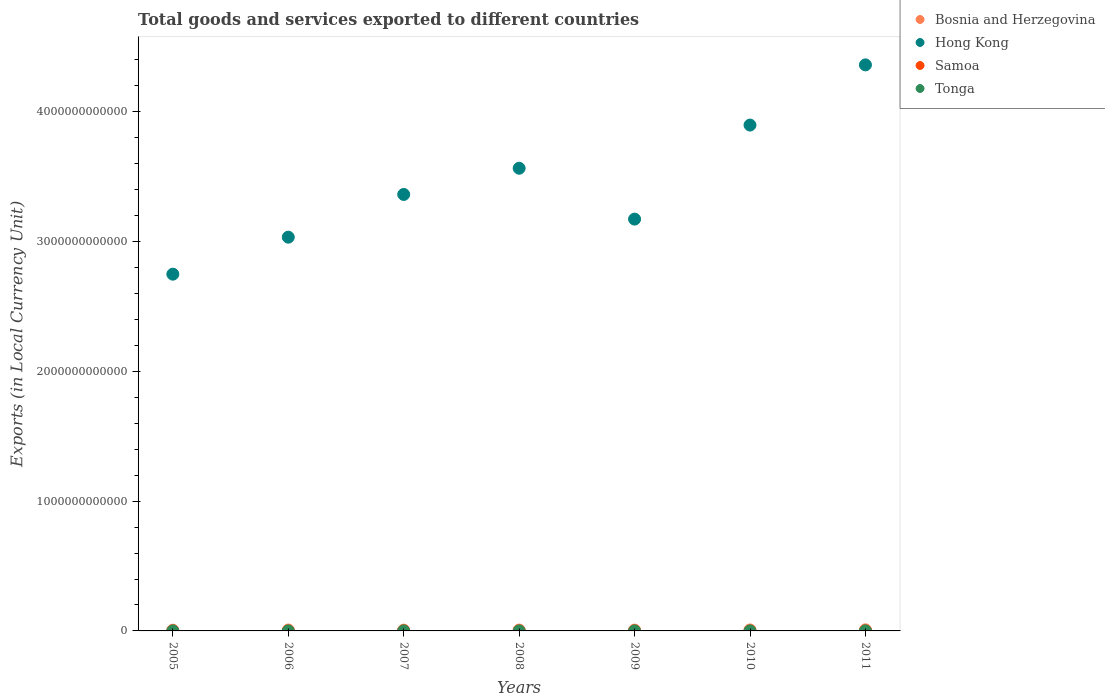Is the number of dotlines equal to the number of legend labels?
Your answer should be very brief. Yes. What is the Amount of goods and services exports in Samoa in 2008?
Offer a terse response. 4.74e+08. Across all years, what is the maximum Amount of goods and services exports in Tonga?
Make the answer very short. 1.29e+08. Across all years, what is the minimum Amount of goods and services exports in Tonga?
Make the answer very short. 7.31e+07. In which year was the Amount of goods and services exports in Tonga minimum?
Offer a terse response. 2007. What is the total Amount of goods and services exports in Samoa in the graph?
Ensure brevity in your answer.  3.15e+09. What is the difference between the Amount of goods and services exports in Bosnia and Herzegovina in 2006 and that in 2011?
Give a very brief answer. -1.38e+09. What is the difference between the Amount of goods and services exports in Hong Kong in 2005 and the Amount of goods and services exports in Samoa in 2010?
Your response must be concise. 2.75e+12. What is the average Amount of goods and services exports in Tonga per year?
Your answer should be very brief. 9.30e+07. In the year 2007, what is the difference between the Amount of goods and services exports in Hong Kong and Amount of goods and services exports in Bosnia and Herzegovina?
Provide a succinct answer. 3.36e+12. What is the ratio of the Amount of goods and services exports in Bosnia and Herzegovina in 2005 to that in 2007?
Your answer should be compact. 0.91. Is the difference between the Amount of goods and services exports in Hong Kong in 2006 and 2011 greater than the difference between the Amount of goods and services exports in Bosnia and Herzegovina in 2006 and 2011?
Ensure brevity in your answer.  No. What is the difference between the highest and the second highest Amount of goods and services exports in Samoa?
Ensure brevity in your answer.  2.37e+07. What is the difference between the highest and the lowest Amount of goods and services exports in Bosnia and Herzegovina?
Provide a succinct answer. 2.82e+09. Is the sum of the Amount of goods and services exports in Tonga in 2005 and 2009 greater than the maximum Amount of goods and services exports in Samoa across all years?
Offer a terse response. No. Is it the case that in every year, the sum of the Amount of goods and services exports in Tonga and Amount of goods and services exports in Hong Kong  is greater than the Amount of goods and services exports in Bosnia and Herzegovina?
Ensure brevity in your answer.  Yes. Does the Amount of goods and services exports in Samoa monotonically increase over the years?
Your answer should be very brief. No. Is the Amount of goods and services exports in Hong Kong strictly greater than the Amount of goods and services exports in Bosnia and Herzegovina over the years?
Give a very brief answer. Yes. Is the Amount of goods and services exports in Samoa strictly less than the Amount of goods and services exports in Bosnia and Herzegovina over the years?
Your answer should be compact. Yes. How many dotlines are there?
Ensure brevity in your answer.  4. How many years are there in the graph?
Offer a very short reply. 7. What is the difference between two consecutive major ticks on the Y-axis?
Your answer should be compact. 1.00e+12. Does the graph contain grids?
Give a very brief answer. No. How are the legend labels stacked?
Your answer should be very brief. Vertical. What is the title of the graph?
Offer a terse response. Total goods and services exported to different countries. What is the label or title of the X-axis?
Offer a very short reply. Years. What is the label or title of the Y-axis?
Offer a very short reply. Exports (in Local Currency Unit). What is the Exports (in Local Currency Unit) in Bosnia and Herzegovina in 2005?
Ensure brevity in your answer.  5.58e+09. What is the Exports (in Local Currency Unit) in Hong Kong in 2005?
Make the answer very short. 2.75e+12. What is the Exports (in Local Currency Unit) in Samoa in 2005?
Your answer should be very brief. 3.58e+08. What is the Exports (in Local Currency Unit) in Tonga in 2005?
Ensure brevity in your answer.  9.05e+07. What is the Exports (in Local Currency Unit) of Bosnia and Herzegovina in 2006?
Your answer should be very brief. 7.02e+09. What is the Exports (in Local Currency Unit) in Hong Kong in 2006?
Keep it short and to the point. 3.03e+12. What is the Exports (in Local Currency Unit) in Samoa in 2006?
Your response must be concise. 4.07e+08. What is the Exports (in Local Currency Unit) of Tonga in 2006?
Offer a very short reply. 8.55e+07. What is the Exports (in Local Currency Unit) of Bosnia and Herzegovina in 2007?
Keep it short and to the point. 6.11e+09. What is the Exports (in Local Currency Unit) of Hong Kong in 2007?
Your answer should be very brief. 3.36e+12. What is the Exports (in Local Currency Unit) of Samoa in 2007?
Make the answer very short. 4.44e+08. What is the Exports (in Local Currency Unit) of Tonga in 2007?
Ensure brevity in your answer.  7.31e+07. What is the Exports (in Local Currency Unit) of Bosnia and Herzegovina in 2008?
Provide a short and direct response. 6.85e+09. What is the Exports (in Local Currency Unit) of Hong Kong in 2008?
Your answer should be compact. 3.56e+12. What is the Exports (in Local Currency Unit) in Samoa in 2008?
Provide a succinct answer. 4.74e+08. What is the Exports (in Local Currency Unit) of Tonga in 2008?
Provide a succinct answer. 9.04e+07. What is the Exports (in Local Currency Unit) in Bosnia and Herzegovina in 2009?
Offer a very short reply. 6.20e+09. What is the Exports (in Local Currency Unit) in Hong Kong in 2009?
Ensure brevity in your answer.  3.17e+12. What is the Exports (in Local Currency Unit) of Samoa in 2009?
Your response must be concise. 4.83e+08. What is the Exports (in Local Currency Unit) of Tonga in 2009?
Make the answer very short. 9.32e+07. What is the Exports (in Local Currency Unit) of Bosnia and Herzegovina in 2010?
Offer a very short reply. 7.53e+09. What is the Exports (in Local Currency Unit) of Hong Kong in 2010?
Offer a very short reply. 3.90e+12. What is the Exports (in Local Currency Unit) in Samoa in 2010?
Provide a short and direct response. 4.77e+08. What is the Exports (in Local Currency Unit) of Tonga in 2010?
Your answer should be very brief. 8.99e+07. What is the Exports (in Local Currency Unit) in Bosnia and Herzegovina in 2011?
Ensure brevity in your answer.  8.40e+09. What is the Exports (in Local Currency Unit) in Hong Kong in 2011?
Provide a succinct answer. 4.36e+12. What is the Exports (in Local Currency Unit) of Samoa in 2011?
Provide a short and direct response. 5.07e+08. What is the Exports (in Local Currency Unit) of Tonga in 2011?
Give a very brief answer. 1.29e+08. Across all years, what is the maximum Exports (in Local Currency Unit) in Bosnia and Herzegovina?
Provide a succinct answer. 8.40e+09. Across all years, what is the maximum Exports (in Local Currency Unit) in Hong Kong?
Keep it short and to the point. 4.36e+12. Across all years, what is the maximum Exports (in Local Currency Unit) in Samoa?
Your answer should be compact. 5.07e+08. Across all years, what is the maximum Exports (in Local Currency Unit) of Tonga?
Your response must be concise. 1.29e+08. Across all years, what is the minimum Exports (in Local Currency Unit) of Bosnia and Herzegovina?
Offer a terse response. 5.58e+09. Across all years, what is the minimum Exports (in Local Currency Unit) of Hong Kong?
Offer a very short reply. 2.75e+12. Across all years, what is the minimum Exports (in Local Currency Unit) in Samoa?
Keep it short and to the point. 3.58e+08. Across all years, what is the minimum Exports (in Local Currency Unit) in Tonga?
Make the answer very short. 7.31e+07. What is the total Exports (in Local Currency Unit) of Bosnia and Herzegovina in the graph?
Provide a short and direct response. 4.77e+1. What is the total Exports (in Local Currency Unit) in Hong Kong in the graph?
Give a very brief answer. 2.41e+13. What is the total Exports (in Local Currency Unit) of Samoa in the graph?
Offer a very short reply. 3.15e+09. What is the total Exports (in Local Currency Unit) of Tonga in the graph?
Offer a terse response. 6.51e+08. What is the difference between the Exports (in Local Currency Unit) of Bosnia and Herzegovina in 2005 and that in 2006?
Provide a succinct answer. -1.44e+09. What is the difference between the Exports (in Local Currency Unit) of Hong Kong in 2005 and that in 2006?
Ensure brevity in your answer.  -2.85e+11. What is the difference between the Exports (in Local Currency Unit) of Samoa in 2005 and that in 2006?
Offer a very short reply. -4.83e+07. What is the difference between the Exports (in Local Currency Unit) of Tonga in 2005 and that in 2006?
Make the answer very short. 5.07e+06. What is the difference between the Exports (in Local Currency Unit) of Bosnia and Herzegovina in 2005 and that in 2007?
Ensure brevity in your answer.  -5.28e+08. What is the difference between the Exports (in Local Currency Unit) of Hong Kong in 2005 and that in 2007?
Your answer should be very brief. -6.14e+11. What is the difference between the Exports (in Local Currency Unit) of Samoa in 2005 and that in 2007?
Provide a short and direct response. -8.52e+07. What is the difference between the Exports (in Local Currency Unit) in Tonga in 2005 and that in 2007?
Ensure brevity in your answer.  1.75e+07. What is the difference between the Exports (in Local Currency Unit) in Bosnia and Herzegovina in 2005 and that in 2008?
Ensure brevity in your answer.  -1.27e+09. What is the difference between the Exports (in Local Currency Unit) of Hong Kong in 2005 and that in 2008?
Your answer should be very brief. -8.16e+11. What is the difference between the Exports (in Local Currency Unit) of Samoa in 2005 and that in 2008?
Give a very brief answer. -1.15e+08. What is the difference between the Exports (in Local Currency Unit) in Tonga in 2005 and that in 2008?
Provide a succinct answer. 1.49e+05. What is the difference between the Exports (in Local Currency Unit) in Bosnia and Herzegovina in 2005 and that in 2009?
Ensure brevity in your answer.  -6.19e+08. What is the difference between the Exports (in Local Currency Unit) in Hong Kong in 2005 and that in 2009?
Ensure brevity in your answer.  -4.24e+11. What is the difference between the Exports (in Local Currency Unit) of Samoa in 2005 and that in 2009?
Give a very brief answer. -1.25e+08. What is the difference between the Exports (in Local Currency Unit) of Tonga in 2005 and that in 2009?
Your answer should be very brief. -2.63e+06. What is the difference between the Exports (in Local Currency Unit) of Bosnia and Herzegovina in 2005 and that in 2010?
Provide a succinct answer. -1.95e+09. What is the difference between the Exports (in Local Currency Unit) of Hong Kong in 2005 and that in 2010?
Your answer should be very brief. -1.15e+12. What is the difference between the Exports (in Local Currency Unit) of Samoa in 2005 and that in 2010?
Your answer should be very brief. -1.18e+08. What is the difference between the Exports (in Local Currency Unit) in Tonga in 2005 and that in 2010?
Provide a short and direct response. 6.74e+05. What is the difference between the Exports (in Local Currency Unit) of Bosnia and Herzegovina in 2005 and that in 2011?
Provide a succinct answer. -2.82e+09. What is the difference between the Exports (in Local Currency Unit) of Hong Kong in 2005 and that in 2011?
Provide a succinct answer. -1.61e+12. What is the difference between the Exports (in Local Currency Unit) of Samoa in 2005 and that in 2011?
Provide a short and direct response. -1.49e+08. What is the difference between the Exports (in Local Currency Unit) in Tonga in 2005 and that in 2011?
Your answer should be compact. -3.80e+07. What is the difference between the Exports (in Local Currency Unit) of Bosnia and Herzegovina in 2006 and that in 2007?
Keep it short and to the point. 9.14e+08. What is the difference between the Exports (in Local Currency Unit) in Hong Kong in 2006 and that in 2007?
Your response must be concise. -3.29e+11. What is the difference between the Exports (in Local Currency Unit) of Samoa in 2006 and that in 2007?
Your answer should be compact. -3.69e+07. What is the difference between the Exports (in Local Currency Unit) in Tonga in 2006 and that in 2007?
Give a very brief answer. 1.24e+07. What is the difference between the Exports (in Local Currency Unit) of Bosnia and Herzegovina in 2006 and that in 2008?
Provide a short and direct response. 1.73e+08. What is the difference between the Exports (in Local Currency Unit) in Hong Kong in 2006 and that in 2008?
Make the answer very short. -5.31e+11. What is the difference between the Exports (in Local Currency Unit) of Samoa in 2006 and that in 2008?
Keep it short and to the point. -6.71e+07. What is the difference between the Exports (in Local Currency Unit) of Tonga in 2006 and that in 2008?
Your response must be concise. -4.92e+06. What is the difference between the Exports (in Local Currency Unit) in Bosnia and Herzegovina in 2006 and that in 2009?
Provide a succinct answer. 8.22e+08. What is the difference between the Exports (in Local Currency Unit) in Hong Kong in 2006 and that in 2009?
Offer a very short reply. -1.39e+11. What is the difference between the Exports (in Local Currency Unit) of Samoa in 2006 and that in 2009?
Ensure brevity in your answer.  -7.65e+07. What is the difference between the Exports (in Local Currency Unit) of Tonga in 2006 and that in 2009?
Give a very brief answer. -7.70e+06. What is the difference between the Exports (in Local Currency Unit) in Bosnia and Herzegovina in 2006 and that in 2010?
Provide a short and direct response. -5.08e+08. What is the difference between the Exports (in Local Currency Unit) of Hong Kong in 2006 and that in 2010?
Offer a terse response. -8.64e+11. What is the difference between the Exports (in Local Currency Unit) of Samoa in 2006 and that in 2010?
Provide a short and direct response. -7.01e+07. What is the difference between the Exports (in Local Currency Unit) of Tonga in 2006 and that in 2010?
Provide a short and direct response. -4.39e+06. What is the difference between the Exports (in Local Currency Unit) of Bosnia and Herzegovina in 2006 and that in 2011?
Provide a succinct answer. -1.38e+09. What is the difference between the Exports (in Local Currency Unit) in Hong Kong in 2006 and that in 2011?
Provide a short and direct response. -1.33e+12. What is the difference between the Exports (in Local Currency Unit) in Samoa in 2006 and that in 2011?
Make the answer very short. -1.00e+08. What is the difference between the Exports (in Local Currency Unit) in Tonga in 2006 and that in 2011?
Ensure brevity in your answer.  -4.30e+07. What is the difference between the Exports (in Local Currency Unit) in Bosnia and Herzegovina in 2007 and that in 2008?
Your answer should be very brief. -7.41e+08. What is the difference between the Exports (in Local Currency Unit) of Hong Kong in 2007 and that in 2008?
Your response must be concise. -2.02e+11. What is the difference between the Exports (in Local Currency Unit) in Samoa in 2007 and that in 2008?
Ensure brevity in your answer.  -3.02e+07. What is the difference between the Exports (in Local Currency Unit) of Tonga in 2007 and that in 2008?
Provide a short and direct response. -1.73e+07. What is the difference between the Exports (in Local Currency Unit) of Bosnia and Herzegovina in 2007 and that in 2009?
Your response must be concise. -9.11e+07. What is the difference between the Exports (in Local Currency Unit) in Hong Kong in 2007 and that in 2009?
Your response must be concise. 1.90e+11. What is the difference between the Exports (in Local Currency Unit) of Samoa in 2007 and that in 2009?
Provide a succinct answer. -3.97e+07. What is the difference between the Exports (in Local Currency Unit) in Tonga in 2007 and that in 2009?
Provide a succinct answer. -2.01e+07. What is the difference between the Exports (in Local Currency Unit) of Bosnia and Herzegovina in 2007 and that in 2010?
Offer a very short reply. -1.42e+09. What is the difference between the Exports (in Local Currency Unit) in Hong Kong in 2007 and that in 2010?
Give a very brief answer. -5.35e+11. What is the difference between the Exports (in Local Currency Unit) of Samoa in 2007 and that in 2010?
Offer a terse response. -3.33e+07. What is the difference between the Exports (in Local Currency Unit) in Tonga in 2007 and that in 2010?
Offer a very short reply. -1.68e+07. What is the difference between the Exports (in Local Currency Unit) of Bosnia and Herzegovina in 2007 and that in 2011?
Keep it short and to the point. -2.29e+09. What is the difference between the Exports (in Local Currency Unit) in Hong Kong in 2007 and that in 2011?
Provide a succinct answer. -9.98e+11. What is the difference between the Exports (in Local Currency Unit) in Samoa in 2007 and that in 2011?
Your answer should be very brief. -6.33e+07. What is the difference between the Exports (in Local Currency Unit) in Tonga in 2007 and that in 2011?
Offer a terse response. -5.55e+07. What is the difference between the Exports (in Local Currency Unit) in Bosnia and Herzegovina in 2008 and that in 2009?
Your answer should be very brief. 6.49e+08. What is the difference between the Exports (in Local Currency Unit) in Hong Kong in 2008 and that in 2009?
Your answer should be very brief. 3.92e+11. What is the difference between the Exports (in Local Currency Unit) of Samoa in 2008 and that in 2009?
Give a very brief answer. -9.49e+06. What is the difference between the Exports (in Local Currency Unit) of Tonga in 2008 and that in 2009?
Offer a very short reply. -2.78e+06. What is the difference between the Exports (in Local Currency Unit) of Bosnia and Herzegovina in 2008 and that in 2010?
Keep it short and to the point. -6.81e+08. What is the difference between the Exports (in Local Currency Unit) in Hong Kong in 2008 and that in 2010?
Offer a terse response. -3.33e+11. What is the difference between the Exports (in Local Currency Unit) in Samoa in 2008 and that in 2010?
Offer a terse response. -3.09e+06. What is the difference between the Exports (in Local Currency Unit) of Tonga in 2008 and that in 2010?
Provide a short and direct response. 5.25e+05. What is the difference between the Exports (in Local Currency Unit) in Bosnia and Herzegovina in 2008 and that in 2011?
Give a very brief answer. -1.55e+09. What is the difference between the Exports (in Local Currency Unit) of Hong Kong in 2008 and that in 2011?
Offer a very short reply. -7.96e+11. What is the difference between the Exports (in Local Currency Unit) of Samoa in 2008 and that in 2011?
Your answer should be very brief. -3.32e+07. What is the difference between the Exports (in Local Currency Unit) of Tonga in 2008 and that in 2011?
Ensure brevity in your answer.  -3.81e+07. What is the difference between the Exports (in Local Currency Unit) of Bosnia and Herzegovina in 2009 and that in 2010?
Offer a terse response. -1.33e+09. What is the difference between the Exports (in Local Currency Unit) of Hong Kong in 2009 and that in 2010?
Keep it short and to the point. -7.25e+11. What is the difference between the Exports (in Local Currency Unit) in Samoa in 2009 and that in 2010?
Ensure brevity in your answer.  6.41e+06. What is the difference between the Exports (in Local Currency Unit) in Tonga in 2009 and that in 2010?
Make the answer very short. 3.31e+06. What is the difference between the Exports (in Local Currency Unit) in Bosnia and Herzegovina in 2009 and that in 2011?
Provide a succinct answer. -2.20e+09. What is the difference between the Exports (in Local Currency Unit) of Hong Kong in 2009 and that in 2011?
Offer a terse response. -1.19e+12. What is the difference between the Exports (in Local Currency Unit) in Samoa in 2009 and that in 2011?
Ensure brevity in your answer.  -2.37e+07. What is the difference between the Exports (in Local Currency Unit) of Tonga in 2009 and that in 2011?
Offer a very short reply. -3.53e+07. What is the difference between the Exports (in Local Currency Unit) in Bosnia and Herzegovina in 2010 and that in 2011?
Your answer should be very brief. -8.71e+08. What is the difference between the Exports (in Local Currency Unit) of Hong Kong in 2010 and that in 2011?
Provide a succinct answer. -4.64e+11. What is the difference between the Exports (in Local Currency Unit) in Samoa in 2010 and that in 2011?
Provide a succinct answer. -3.01e+07. What is the difference between the Exports (in Local Currency Unit) in Tonga in 2010 and that in 2011?
Provide a short and direct response. -3.86e+07. What is the difference between the Exports (in Local Currency Unit) of Bosnia and Herzegovina in 2005 and the Exports (in Local Currency Unit) of Hong Kong in 2006?
Give a very brief answer. -3.03e+12. What is the difference between the Exports (in Local Currency Unit) of Bosnia and Herzegovina in 2005 and the Exports (in Local Currency Unit) of Samoa in 2006?
Your answer should be compact. 5.18e+09. What is the difference between the Exports (in Local Currency Unit) in Bosnia and Herzegovina in 2005 and the Exports (in Local Currency Unit) in Tonga in 2006?
Ensure brevity in your answer.  5.50e+09. What is the difference between the Exports (in Local Currency Unit) in Hong Kong in 2005 and the Exports (in Local Currency Unit) in Samoa in 2006?
Provide a short and direct response. 2.75e+12. What is the difference between the Exports (in Local Currency Unit) of Hong Kong in 2005 and the Exports (in Local Currency Unit) of Tonga in 2006?
Give a very brief answer. 2.75e+12. What is the difference between the Exports (in Local Currency Unit) of Samoa in 2005 and the Exports (in Local Currency Unit) of Tonga in 2006?
Your answer should be compact. 2.73e+08. What is the difference between the Exports (in Local Currency Unit) of Bosnia and Herzegovina in 2005 and the Exports (in Local Currency Unit) of Hong Kong in 2007?
Provide a short and direct response. -3.36e+12. What is the difference between the Exports (in Local Currency Unit) of Bosnia and Herzegovina in 2005 and the Exports (in Local Currency Unit) of Samoa in 2007?
Offer a terse response. 5.14e+09. What is the difference between the Exports (in Local Currency Unit) of Bosnia and Herzegovina in 2005 and the Exports (in Local Currency Unit) of Tonga in 2007?
Make the answer very short. 5.51e+09. What is the difference between the Exports (in Local Currency Unit) in Hong Kong in 2005 and the Exports (in Local Currency Unit) in Samoa in 2007?
Provide a short and direct response. 2.75e+12. What is the difference between the Exports (in Local Currency Unit) of Hong Kong in 2005 and the Exports (in Local Currency Unit) of Tonga in 2007?
Give a very brief answer. 2.75e+12. What is the difference between the Exports (in Local Currency Unit) of Samoa in 2005 and the Exports (in Local Currency Unit) of Tonga in 2007?
Your answer should be very brief. 2.85e+08. What is the difference between the Exports (in Local Currency Unit) in Bosnia and Herzegovina in 2005 and the Exports (in Local Currency Unit) in Hong Kong in 2008?
Give a very brief answer. -3.56e+12. What is the difference between the Exports (in Local Currency Unit) in Bosnia and Herzegovina in 2005 and the Exports (in Local Currency Unit) in Samoa in 2008?
Your response must be concise. 5.11e+09. What is the difference between the Exports (in Local Currency Unit) in Bosnia and Herzegovina in 2005 and the Exports (in Local Currency Unit) in Tonga in 2008?
Give a very brief answer. 5.49e+09. What is the difference between the Exports (in Local Currency Unit) of Hong Kong in 2005 and the Exports (in Local Currency Unit) of Samoa in 2008?
Ensure brevity in your answer.  2.75e+12. What is the difference between the Exports (in Local Currency Unit) in Hong Kong in 2005 and the Exports (in Local Currency Unit) in Tonga in 2008?
Your answer should be very brief. 2.75e+12. What is the difference between the Exports (in Local Currency Unit) of Samoa in 2005 and the Exports (in Local Currency Unit) of Tonga in 2008?
Your answer should be very brief. 2.68e+08. What is the difference between the Exports (in Local Currency Unit) of Bosnia and Herzegovina in 2005 and the Exports (in Local Currency Unit) of Hong Kong in 2009?
Make the answer very short. -3.17e+12. What is the difference between the Exports (in Local Currency Unit) in Bosnia and Herzegovina in 2005 and the Exports (in Local Currency Unit) in Samoa in 2009?
Keep it short and to the point. 5.10e+09. What is the difference between the Exports (in Local Currency Unit) in Bosnia and Herzegovina in 2005 and the Exports (in Local Currency Unit) in Tonga in 2009?
Make the answer very short. 5.49e+09. What is the difference between the Exports (in Local Currency Unit) of Hong Kong in 2005 and the Exports (in Local Currency Unit) of Samoa in 2009?
Give a very brief answer. 2.75e+12. What is the difference between the Exports (in Local Currency Unit) in Hong Kong in 2005 and the Exports (in Local Currency Unit) in Tonga in 2009?
Keep it short and to the point. 2.75e+12. What is the difference between the Exports (in Local Currency Unit) in Samoa in 2005 and the Exports (in Local Currency Unit) in Tonga in 2009?
Ensure brevity in your answer.  2.65e+08. What is the difference between the Exports (in Local Currency Unit) in Bosnia and Herzegovina in 2005 and the Exports (in Local Currency Unit) in Hong Kong in 2010?
Offer a very short reply. -3.89e+12. What is the difference between the Exports (in Local Currency Unit) of Bosnia and Herzegovina in 2005 and the Exports (in Local Currency Unit) of Samoa in 2010?
Offer a very short reply. 5.11e+09. What is the difference between the Exports (in Local Currency Unit) of Bosnia and Herzegovina in 2005 and the Exports (in Local Currency Unit) of Tonga in 2010?
Your answer should be very brief. 5.49e+09. What is the difference between the Exports (in Local Currency Unit) of Hong Kong in 2005 and the Exports (in Local Currency Unit) of Samoa in 2010?
Offer a very short reply. 2.75e+12. What is the difference between the Exports (in Local Currency Unit) in Hong Kong in 2005 and the Exports (in Local Currency Unit) in Tonga in 2010?
Your answer should be compact. 2.75e+12. What is the difference between the Exports (in Local Currency Unit) of Samoa in 2005 and the Exports (in Local Currency Unit) of Tonga in 2010?
Your response must be concise. 2.68e+08. What is the difference between the Exports (in Local Currency Unit) of Bosnia and Herzegovina in 2005 and the Exports (in Local Currency Unit) of Hong Kong in 2011?
Your response must be concise. -4.36e+12. What is the difference between the Exports (in Local Currency Unit) of Bosnia and Herzegovina in 2005 and the Exports (in Local Currency Unit) of Samoa in 2011?
Your answer should be very brief. 5.08e+09. What is the difference between the Exports (in Local Currency Unit) in Bosnia and Herzegovina in 2005 and the Exports (in Local Currency Unit) in Tonga in 2011?
Offer a terse response. 5.45e+09. What is the difference between the Exports (in Local Currency Unit) of Hong Kong in 2005 and the Exports (in Local Currency Unit) of Samoa in 2011?
Provide a succinct answer. 2.75e+12. What is the difference between the Exports (in Local Currency Unit) in Hong Kong in 2005 and the Exports (in Local Currency Unit) in Tonga in 2011?
Your answer should be compact. 2.75e+12. What is the difference between the Exports (in Local Currency Unit) of Samoa in 2005 and the Exports (in Local Currency Unit) of Tonga in 2011?
Your answer should be compact. 2.30e+08. What is the difference between the Exports (in Local Currency Unit) in Bosnia and Herzegovina in 2006 and the Exports (in Local Currency Unit) in Hong Kong in 2007?
Offer a very short reply. -3.36e+12. What is the difference between the Exports (in Local Currency Unit) of Bosnia and Herzegovina in 2006 and the Exports (in Local Currency Unit) of Samoa in 2007?
Keep it short and to the point. 6.58e+09. What is the difference between the Exports (in Local Currency Unit) of Bosnia and Herzegovina in 2006 and the Exports (in Local Currency Unit) of Tonga in 2007?
Offer a terse response. 6.95e+09. What is the difference between the Exports (in Local Currency Unit) of Hong Kong in 2006 and the Exports (in Local Currency Unit) of Samoa in 2007?
Give a very brief answer. 3.03e+12. What is the difference between the Exports (in Local Currency Unit) of Hong Kong in 2006 and the Exports (in Local Currency Unit) of Tonga in 2007?
Keep it short and to the point. 3.03e+12. What is the difference between the Exports (in Local Currency Unit) in Samoa in 2006 and the Exports (in Local Currency Unit) in Tonga in 2007?
Keep it short and to the point. 3.34e+08. What is the difference between the Exports (in Local Currency Unit) of Bosnia and Herzegovina in 2006 and the Exports (in Local Currency Unit) of Hong Kong in 2008?
Your response must be concise. -3.56e+12. What is the difference between the Exports (in Local Currency Unit) in Bosnia and Herzegovina in 2006 and the Exports (in Local Currency Unit) in Samoa in 2008?
Ensure brevity in your answer.  6.55e+09. What is the difference between the Exports (in Local Currency Unit) in Bosnia and Herzegovina in 2006 and the Exports (in Local Currency Unit) in Tonga in 2008?
Your answer should be compact. 6.93e+09. What is the difference between the Exports (in Local Currency Unit) in Hong Kong in 2006 and the Exports (in Local Currency Unit) in Samoa in 2008?
Ensure brevity in your answer.  3.03e+12. What is the difference between the Exports (in Local Currency Unit) of Hong Kong in 2006 and the Exports (in Local Currency Unit) of Tonga in 2008?
Your answer should be very brief. 3.03e+12. What is the difference between the Exports (in Local Currency Unit) of Samoa in 2006 and the Exports (in Local Currency Unit) of Tonga in 2008?
Your response must be concise. 3.16e+08. What is the difference between the Exports (in Local Currency Unit) in Bosnia and Herzegovina in 2006 and the Exports (in Local Currency Unit) in Hong Kong in 2009?
Ensure brevity in your answer.  -3.17e+12. What is the difference between the Exports (in Local Currency Unit) in Bosnia and Herzegovina in 2006 and the Exports (in Local Currency Unit) in Samoa in 2009?
Offer a very short reply. 6.54e+09. What is the difference between the Exports (in Local Currency Unit) of Bosnia and Herzegovina in 2006 and the Exports (in Local Currency Unit) of Tonga in 2009?
Give a very brief answer. 6.93e+09. What is the difference between the Exports (in Local Currency Unit) in Hong Kong in 2006 and the Exports (in Local Currency Unit) in Samoa in 2009?
Keep it short and to the point. 3.03e+12. What is the difference between the Exports (in Local Currency Unit) of Hong Kong in 2006 and the Exports (in Local Currency Unit) of Tonga in 2009?
Ensure brevity in your answer.  3.03e+12. What is the difference between the Exports (in Local Currency Unit) in Samoa in 2006 and the Exports (in Local Currency Unit) in Tonga in 2009?
Ensure brevity in your answer.  3.13e+08. What is the difference between the Exports (in Local Currency Unit) of Bosnia and Herzegovina in 2006 and the Exports (in Local Currency Unit) of Hong Kong in 2010?
Your response must be concise. -3.89e+12. What is the difference between the Exports (in Local Currency Unit) in Bosnia and Herzegovina in 2006 and the Exports (in Local Currency Unit) in Samoa in 2010?
Make the answer very short. 6.55e+09. What is the difference between the Exports (in Local Currency Unit) in Bosnia and Herzegovina in 2006 and the Exports (in Local Currency Unit) in Tonga in 2010?
Provide a short and direct response. 6.93e+09. What is the difference between the Exports (in Local Currency Unit) in Hong Kong in 2006 and the Exports (in Local Currency Unit) in Samoa in 2010?
Your answer should be very brief. 3.03e+12. What is the difference between the Exports (in Local Currency Unit) of Hong Kong in 2006 and the Exports (in Local Currency Unit) of Tonga in 2010?
Keep it short and to the point. 3.03e+12. What is the difference between the Exports (in Local Currency Unit) in Samoa in 2006 and the Exports (in Local Currency Unit) in Tonga in 2010?
Give a very brief answer. 3.17e+08. What is the difference between the Exports (in Local Currency Unit) in Bosnia and Herzegovina in 2006 and the Exports (in Local Currency Unit) in Hong Kong in 2011?
Your answer should be very brief. -4.35e+12. What is the difference between the Exports (in Local Currency Unit) in Bosnia and Herzegovina in 2006 and the Exports (in Local Currency Unit) in Samoa in 2011?
Provide a succinct answer. 6.52e+09. What is the difference between the Exports (in Local Currency Unit) in Bosnia and Herzegovina in 2006 and the Exports (in Local Currency Unit) in Tonga in 2011?
Make the answer very short. 6.90e+09. What is the difference between the Exports (in Local Currency Unit) in Hong Kong in 2006 and the Exports (in Local Currency Unit) in Samoa in 2011?
Provide a succinct answer. 3.03e+12. What is the difference between the Exports (in Local Currency Unit) in Hong Kong in 2006 and the Exports (in Local Currency Unit) in Tonga in 2011?
Your answer should be very brief. 3.03e+12. What is the difference between the Exports (in Local Currency Unit) in Samoa in 2006 and the Exports (in Local Currency Unit) in Tonga in 2011?
Your answer should be very brief. 2.78e+08. What is the difference between the Exports (in Local Currency Unit) of Bosnia and Herzegovina in 2007 and the Exports (in Local Currency Unit) of Hong Kong in 2008?
Ensure brevity in your answer.  -3.56e+12. What is the difference between the Exports (in Local Currency Unit) of Bosnia and Herzegovina in 2007 and the Exports (in Local Currency Unit) of Samoa in 2008?
Ensure brevity in your answer.  5.64e+09. What is the difference between the Exports (in Local Currency Unit) of Bosnia and Herzegovina in 2007 and the Exports (in Local Currency Unit) of Tonga in 2008?
Keep it short and to the point. 6.02e+09. What is the difference between the Exports (in Local Currency Unit) of Hong Kong in 2007 and the Exports (in Local Currency Unit) of Samoa in 2008?
Provide a short and direct response. 3.36e+12. What is the difference between the Exports (in Local Currency Unit) of Hong Kong in 2007 and the Exports (in Local Currency Unit) of Tonga in 2008?
Your response must be concise. 3.36e+12. What is the difference between the Exports (in Local Currency Unit) in Samoa in 2007 and the Exports (in Local Currency Unit) in Tonga in 2008?
Offer a very short reply. 3.53e+08. What is the difference between the Exports (in Local Currency Unit) of Bosnia and Herzegovina in 2007 and the Exports (in Local Currency Unit) of Hong Kong in 2009?
Give a very brief answer. -3.17e+12. What is the difference between the Exports (in Local Currency Unit) of Bosnia and Herzegovina in 2007 and the Exports (in Local Currency Unit) of Samoa in 2009?
Your answer should be very brief. 5.63e+09. What is the difference between the Exports (in Local Currency Unit) of Bosnia and Herzegovina in 2007 and the Exports (in Local Currency Unit) of Tonga in 2009?
Offer a terse response. 6.02e+09. What is the difference between the Exports (in Local Currency Unit) in Hong Kong in 2007 and the Exports (in Local Currency Unit) in Samoa in 2009?
Provide a short and direct response. 3.36e+12. What is the difference between the Exports (in Local Currency Unit) in Hong Kong in 2007 and the Exports (in Local Currency Unit) in Tonga in 2009?
Your answer should be compact. 3.36e+12. What is the difference between the Exports (in Local Currency Unit) in Samoa in 2007 and the Exports (in Local Currency Unit) in Tonga in 2009?
Offer a very short reply. 3.50e+08. What is the difference between the Exports (in Local Currency Unit) in Bosnia and Herzegovina in 2007 and the Exports (in Local Currency Unit) in Hong Kong in 2010?
Provide a succinct answer. -3.89e+12. What is the difference between the Exports (in Local Currency Unit) in Bosnia and Herzegovina in 2007 and the Exports (in Local Currency Unit) in Samoa in 2010?
Ensure brevity in your answer.  5.63e+09. What is the difference between the Exports (in Local Currency Unit) of Bosnia and Herzegovina in 2007 and the Exports (in Local Currency Unit) of Tonga in 2010?
Your answer should be compact. 6.02e+09. What is the difference between the Exports (in Local Currency Unit) in Hong Kong in 2007 and the Exports (in Local Currency Unit) in Samoa in 2010?
Offer a very short reply. 3.36e+12. What is the difference between the Exports (in Local Currency Unit) in Hong Kong in 2007 and the Exports (in Local Currency Unit) in Tonga in 2010?
Keep it short and to the point. 3.36e+12. What is the difference between the Exports (in Local Currency Unit) in Samoa in 2007 and the Exports (in Local Currency Unit) in Tonga in 2010?
Your answer should be very brief. 3.54e+08. What is the difference between the Exports (in Local Currency Unit) of Bosnia and Herzegovina in 2007 and the Exports (in Local Currency Unit) of Hong Kong in 2011?
Ensure brevity in your answer.  -4.36e+12. What is the difference between the Exports (in Local Currency Unit) of Bosnia and Herzegovina in 2007 and the Exports (in Local Currency Unit) of Samoa in 2011?
Keep it short and to the point. 5.60e+09. What is the difference between the Exports (in Local Currency Unit) in Bosnia and Herzegovina in 2007 and the Exports (in Local Currency Unit) in Tonga in 2011?
Your answer should be very brief. 5.98e+09. What is the difference between the Exports (in Local Currency Unit) of Hong Kong in 2007 and the Exports (in Local Currency Unit) of Samoa in 2011?
Offer a very short reply. 3.36e+12. What is the difference between the Exports (in Local Currency Unit) in Hong Kong in 2007 and the Exports (in Local Currency Unit) in Tonga in 2011?
Ensure brevity in your answer.  3.36e+12. What is the difference between the Exports (in Local Currency Unit) of Samoa in 2007 and the Exports (in Local Currency Unit) of Tonga in 2011?
Offer a terse response. 3.15e+08. What is the difference between the Exports (in Local Currency Unit) of Bosnia and Herzegovina in 2008 and the Exports (in Local Currency Unit) of Hong Kong in 2009?
Provide a succinct answer. -3.17e+12. What is the difference between the Exports (in Local Currency Unit) of Bosnia and Herzegovina in 2008 and the Exports (in Local Currency Unit) of Samoa in 2009?
Make the answer very short. 6.37e+09. What is the difference between the Exports (in Local Currency Unit) in Bosnia and Herzegovina in 2008 and the Exports (in Local Currency Unit) in Tonga in 2009?
Offer a terse response. 6.76e+09. What is the difference between the Exports (in Local Currency Unit) in Hong Kong in 2008 and the Exports (in Local Currency Unit) in Samoa in 2009?
Your answer should be compact. 3.56e+12. What is the difference between the Exports (in Local Currency Unit) in Hong Kong in 2008 and the Exports (in Local Currency Unit) in Tonga in 2009?
Provide a short and direct response. 3.56e+12. What is the difference between the Exports (in Local Currency Unit) in Samoa in 2008 and the Exports (in Local Currency Unit) in Tonga in 2009?
Make the answer very short. 3.81e+08. What is the difference between the Exports (in Local Currency Unit) in Bosnia and Herzegovina in 2008 and the Exports (in Local Currency Unit) in Hong Kong in 2010?
Keep it short and to the point. -3.89e+12. What is the difference between the Exports (in Local Currency Unit) in Bosnia and Herzegovina in 2008 and the Exports (in Local Currency Unit) in Samoa in 2010?
Provide a succinct answer. 6.37e+09. What is the difference between the Exports (in Local Currency Unit) in Bosnia and Herzegovina in 2008 and the Exports (in Local Currency Unit) in Tonga in 2010?
Provide a short and direct response. 6.76e+09. What is the difference between the Exports (in Local Currency Unit) in Hong Kong in 2008 and the Exports (in Local Currency Unit) in Samoa in 2010?
Give a very brief answer. 3.56e+12. What is the difference between the Exports (in Local Currency Unit) of Hong Kong in 2008 and the Exports (in Local Currency Unit) of Tonga in 2010?
Provide a succinct answer. 3.56e+12. What is the difference between the Exports (in Local Currency Unit) of Samoa in 2008 and the Exports (in Local Currency Unit) of Tonga in 2010?
Provide a succinct answer. 3.84e+08. What is the difference between the Exports (in Local Currency Unit) in Bosnia and Herzegovina in 2008 and the Exports (in Local Currency Unit) in Hong Kong in 2011?
Ensure brevity in your answer.  -4.35e+12. What is the difference between the Exports (in Local Currency Unit) of Bosnia and Herzegovina in 2008 and the Exports (in Local Currency Unit) of Samoa in 2011?
Keep it short and to the point. 6.34e+09. What is the difference between the Exports (in Local Currency Unit) in Bosnia and Herzegovina in 2008 and the Exports (in Local Currency Unit) in Tonga in 2011?
Your answer should be compact. 6.72e+09. What is the difference between the Exports (in Local Currency Unit) in Hong Kong in 2008 and the Exports (in Local Currency Unit) in Samoa in 2011?
Offer a terse response. 3.56e+12. What is the difference between the Exports (in Local Currency Unit) of Hong Kong in 2008 and the Exports (in Local Currency Unit) of Tonga in 2011?
Make the answer very short. 3.56e+12. What is the difference between the Exports (in Local Currency Unit) in Samoa in 2008 and the Exports (in Local Currency Unit) in Tonga in 2011?
Make the answer very short. 3.45e+08. What is the difference between the Exports (in Local Currency Unit) of Bosnia and Herzegovina in 2009 and the Exports (in Local Currency Unit) of Hong Kong in 2010?
Your response must be concise. -3.89e+12. What is the difference between the Exports (in Local Currency Unit) of Bosnia and Herzegovina in 2009 and the Exports (in Local Currency Unit) of Samoa in 2010?
Keep it short and to the point. 5.73e+09. What is the difference between the Exports (in Local Currency Unit) in Bosnia and Herzegovina in 2009 and the Exports (in Local Currency Unit) in Tonga in 2010?
Your response must be concise. 6.11e+09. What is the difference between the Exports (in Local Currency Unit) of Hong Kong in 2009 and the Exports (in Local Currency Unit) of Samoa in 2010?
Keep it short and to the point. 3.17e+12. What is the difference between the Exports (in Local Currency Unit) in Hong Kong in 2009 and the Exports (in Local Currency Unit) in Tonga in 2010?
Keep it short and to the point. 3.17e+12. What is the difference between the Exports (in Local Currency Unit) in Samoa in 2009 and the Exports (in Local Currency Unit) in Tonga in 2010?
Give a very brief answer. 3.93e+08. What is the difference between the Exports (in Local Currency Unit) in Bosnia and Herzegovina in 2009 and the Exports (in Local Currency Unit) in Hong Kong in 2011?
Offer a terse response. -4.36e+12. What is the difference between the Exports (in Local Currency Unit) in Bosnia and Herzegovina in 2009 and the Exports (in Local Currency Unit) in Samoa in 2011?
Offer a terse response. 5.70e+09. What is the difference between the Exports (in Local Currency Unit) of Bosnia and Herzegovina in 2009 and the Exports (in Local Currency Unit) of Tonga in 2011?
Keep it short and to the point. 6.07e+09. What is the difference between the Exports (in Local Currency Unit) of Hong Kong in 2009 and the Exports (in Local Currency Unit) of Samoa in 2011?
Offer a very short reply. 3.17e+12. What is the difference between the Exports (in Local Currency Unit) in Hong Kong in 2009 and the Exports (in Local Currency Unit) in Tonga in 2011?
Your answer should be very brief. 3.17e+12. What is the difference between the Exports (in Local Currency Unit) of Samoa in 2009 and the Exports (in Local Currency Unit) of Tonga in 2011?
Your answer should be compact. 3.55e+08. What is the difference between the Exports (in Local Currency Unit) in Bosnia and Herzegovina in 2010 and the Exports (in Local Currency Unit) in Hong Kong in 2011?
Your response must be concise. -4.35e+12. What is the difference between the Exports (in Local Currency Unit) of Bosnia and Herzegovina in 2010 and the Exports (in Local Currency Unit) of Samoa in 2011?
Make the answer very short. 7.03e+09. What is the difference between the Exports (in Local Currency Unit) in Bosnia and Herzegovina in 2010 and the Exports (in Local Currency Unit) in Tonga in 2011?
Give a very brief answer. 7.40e+09. What is the difference between the Exports (in Local Currency Unit) of Hong Kong in 2010 and the Exports (in Local Currency Unit) of Samoa in 2011?
Provide a short and direct response. 3.90e+12. What is the difference between the Exports (in Local Currency Unit) in Hong Kong in 2010 and the Exports (in Local Currency Unit) in Tonga in 2011?
Provide a short and direct response. 3.90e+12. What is the difference between the Exports (in Local Currency Unit) in Samoa in 2010 and the Exports (in Local Currency Unit) in Tonga in 2011?
Offer a terse response. 3.48e+08. What is the average Exports (in Local Currency Unit) in Bosnia and Herzegovina per year?
Provide a succinct answer. 6.82e+09. What is the average Exports (in Local Currency Unit) of Hong Kong per year?
Offer a very short reply. 3.45e+12. What is the average Exports (in Local Currency Unit) of Samoa per year?
Your answer should be compact. 4.50e+08. What is the average Exports (in Local Currency Unit) in Tonga per year?
Provide a succinct answer. 9.30e+07. In the year 2005, what is the difference between the Exports (in Local Currency Unit) of Bosnia and Herzegovina and Exports (in Local Currency Unit) of Hong Kong?
Your answer should be very brief. -2.74e+12. In the year 2005, what is the difference between the Exports (in Local Currency Unit) of Bosnia and Herzegovina and Exports (in Local Currency Unit) of Samoa?
Your response must be concise. 5.22e+09. In the year 2005, what is the difference between the Exports (in Local Currency Unit) in Bosnia and Herzegovina and Exports (in Local Currency Unit) in Tonga?
Offer a terse response. 5.49e+09. In the year 2005, what is the difference between the Exports (in Local Currency Unit) in Hong Kong and Exports (in Local Currency Unit) in Samoa?
Make the answer very short. 2.75e+12. In the year 2005, what is the difference between the Exports (in Local Currency Unit) in Hong Kong and Exports (in Local Currency Unit) in Tonga?
Your answer should be very brief. 2.75e+12. In the year 2005, what is the difference between the Exports (in Local Currency Unit) of Samoa and Exports (in Local Currency Unit) of Tonga?
Your answer should be very brief. 2.68e+08. In the year 2006, what is the difference between the Exports (in Local Currency Unit) in Bosnia and Herzegovina and Exports (in Local Currency Unit) in Hong Kong?
Provide a succinct answer. -3.03e+12. In the year 2006, what is the difference between the Exports (in Local Currency Unit) in Bosnia and Herzegovina and Exports (in Local Currency Unit) in Samoa?
Your answer should be very brief. 6.62e+09. In the year 2006, what is the difference between the Exports (in Local Currency Unit) of Bosnia and Herzegovina and Exports (in Local Currency Unit) of Tonga?
Give a very brief answer. 6.94e+09. In the year 2006, what is the difference between the Exports (in Local Currency Unit) in Hong Kong and Exports (in Local Currency Unit) in Samoa?
Offer a very short reply. 3.03e+12. In the year 2006, what is the difference between the Exports (in Local Currency Unit) of Hong Kong and Exports (in Local Currency Unit) of Tonga?
Your answer should be very brief. 3.03e+12. In the year 2006, what is the difference between the Exports (in Local Currency Unit) in Samoa and Exports (in Local Currency Unit) in Tonga?
Provide a succinct answer. 3.21e+08. In the year 2007, what is the difference between the Exports (in Local Currency Unit) of Bosnia and Herzegovina and Exports (in Local Currency Unit) of Hong Kong?
Your answer should be very brief. -3.36e+12. In the year 2007, what is the difference between the Exports (in Local Currency Unit) of Bosnia and Herzegovina and Exports (in Local Currency Unit) of Samoa?
Give a very brief answer. 5.67e+09. In the year 2007, what is the difference between the Exports (in Local Currency Unit) of Bosnia and Herzegovina and Exports (in Local Currency Unit) of Tonga?
Provide a short and direct response. 6.04e+09. In the year 2007, what is the difference between the Exports (in Local Currency Unit) in Hong Kong and Exports (in Local Currency Unit) in Samoa?
Your answer should be compact. 3.36e+12. In the year 2007, what is the difference between the Exports (in Local Currency Unit) in Hong Kong and Exports (in Local Currency Unit) in Tonga?
Provide a succinct answer. 3.36e+12. In the year 2007, what is the difference between the Exports (in Local Currency Unit) in Samoa and Exports (in Local Currency Unit) in Tonga?
Provide a short and direct response. 3.70e+08. In the year 2008, what is the difference between the Exports (in Local Currency Unit) of Bosnia and Herzegovina and Exports (in Local Currency Unit) of Hong Kong?
Provide a succinct answer. -3.56e+12. In the year 2008, what is the difference between the Exports (in Local Currency Unit) of Bosnia and Herzegovina and Exports (in Local Currency Unit) of Samoa?
Ensure brevity in your answer.  6.38e+09. In the year 2008, what is the difference between the Exports (in Local Currency Unit) of Bosnia and Herzegovina and Exports (in Local Currency Unit) of Tonga?
Provide a succinct answer. 6.76e+09. In the year 2008, what is the difference between the Exports (in Local Currency Unit) in Hong Kong and Exports (in Local Currency Unit) in Samoa?
Ensure brevity in your answer.  3.56e+12. In the year 2008, what is the difference between the Exports (in Local Currency Unit) in Hong Kong and Exports (in Local Currency Unit) in Tonga?
Offer a very short reply. 3.56e+12. In the year 2008, what is the difference between the Exports (in Local Currency Unit) in Samoa and Exports (in Local Currency Unit) in Tonga?
Your answer should be very brief. 3.83e+08. In the year 2009, what is the difference between the Exports (in Local Currency Unit) in Bosnia and Herzegovina and Exports (in Local Currency Unit) in Hong Kong?
Provide a short and direct response. -3.17e+12. In the year 2009, what is the difference between the Exports (in Local Currency Unit) of Bosnia and Herzegovina and Exports (in Local Currency Unit) of Samoa?
Your response must be concise. 5.72e+09. In the year 2009, what is the difference between the Exports (in Local Currency Unit) in Bosnia and Herzegovina and Exports (in Local Currency Unit) in Tonga?
Your response must be concise. 6.11e+09. In the year 2009, what is the difference between the Exports (in Local Currency Unit) of Hong Kong and Exports (in Local Currency Unit) of Samoa?
Your response must be concise. 3.17e+12. In the year 2009, what is the difference between the Exports (in Local Currency Unit) of Hong Kong and Exports (in Local Currency Unit) of Tonga?
Ensure brevity in your answer.  3.17e+12. In the year 2009, what is the difference between the Exports (in Local Currency Unit) of Samoa and Exports (in Local Currency Unit) of Tonga?
Your answer should be compact. 3.90e+08. In the year 2010, what is the difference between the Exports (in Local Currency Unit) of Bosnia and Herzegovina and Exports (in Local Currency Unit) of Hong Kong?
Provide a succinct answer. -3.89e+12. In the year 2010, what is the difference between the Exports (in Local Currency Unit) of Bosnia and Herzegovina and Exports (in Local Currency Unit) of Samoa?
Provide a succinct answer. 7.06e+09. In the year 2010, what is the difference between the Exports (in Local Currency Unit) in Bosnia and Herzegovina and Exports (in Local Currency Unit) in Tonga?
Make the answer very short. 7.44e+09. In the year 2010, what is the difference between the Exports (in Local Currency Unit) of Hong Kong and Exports (in Local Currency Unit) of Samoa?
Ensure brevity in your answer.  3.90e+12. In the year 2010, what is the difference between the Exports (in Local Currency Unit) of Hong Kong and Exports (in Local Currency Unit) of Tonga?
Keep it short and to the point. 3.90e+12. In the year 2010, what is the difference between the Exports (in Local Currency Unit) in Samoa and Exports (in Local Currency Unit) in Tonga?
Make the answer very short. 3.87e+08. In the year 2011, what is the difference between the Exports (in Local Currency Unit) in Bosnia and Herzegovina and Exports (in Local Currency Unit) in Hong Kong?
Keep it short and to the point. -4.35e+12. In the year 2011, what is the difference between the Exports (in Local Currency Unit) in Bosnia and Herzegovina and Exports (in Local Currency Unit) in Samoa?
Your answer should be very brief. 7.90e+09. In the year 2011, what is the difference between the Exports (in Local Currency Unit) of Bosnia and Herzegovina and Exports (in Local Currency Unit) of Tonga?
Make the answer very short. 8.27e+09. In the year 2011, what is the difference between the Exports (in Local Currency Unit) in Hong Kong and Exports (in Local Currency Unit) in Samoa?
Offer a terse response. 4.36e+12. In the year 2011, what is the difference between the Exports (in Local Currency Unit) of Hong Kong and Exports (in Local Currency Unit) of Tonga?
Offer a very short reply. 4.36e+12. In the year 2011, what is the difference between the Exports (in Local Currency Unit) in Samoa and Exports (in Local Currency Unit) in Tonga?
Ensure brevity in your answer.  3.78e+08. What is the ratio of the Exports (in Local Currency Unit) in Bosnia and Herzegovina in 2005 to that in 2006?
Ensure brevity in your answer.  0.79. What is the ratio of the Exports (in Local Currency Unit) of Hong Kong in 2005 to that in 2006?
Your answer should be compact. 0.91. What is the ratio of the Exports (in Local Currency Unit) in Samoa in 2005 to that in 2006?
Make the answer very short. 0.88. What is the ratio of the Exports (in Local Currency Unit) in Tonga in 2005 to that in 2006?
Provide a short and direct response. 1.06. What is the ratio of the Exports (in Local Currency Unit) of Bosnia and Herzegovina in 2005 to that in 2007?
Your answer should be very brief. 0.91. What is the ratio of the Exports (in Local Currency Unit) of Hong Kong in 2005 to that in 2007?
Offer a very short reply. 0.82. What is the ratio of the Exports (in Local Currency Unit) of Samoa in 2005 to that in 2007?
Keep it short and to the point. 0.81. What is the ratio of the Exports (in Local Currency Unit) of Tonga in 2005 to that in 2007?
Offer a very short reply. 1.24. What is the ratio of the Exports (in Local Currency Unit) in Bosnia and Herzegovina in 2005 to that in 2008?
Your answer should be compact. 0.81. What is the ratio of the Exports (in Local Currency Unit) of Hong Kong in 2005 to that in 2008?
Make the answer very short. 0.77. What is the ratio of the Exports (in Local Currency Unit) in Samoa in 2005 to that in 2008?
Ensure brevity in your answer.  0.76. What is the ratio of the Exports (in Local Currency Unit) in Bosnia and Herzegovina in 2005 to that in 2009?
Make the answer very short. 0.9. What is the ratio of the Exports (in Local Currency Unit) of Hong Kong in 2005 to that in 2009?
Provide a short and direct response. 0.87. What is the ratio of the Exports (in Local Currency Unit) in Samoa in 2005 to that in 2009?
Your response must be concise. 0.74. What is the ratio of the Exports (in Local Currency Unit) of Tonga in 2005 to that in 2009?
Offer a terse response. 0.97. What is the ratio of the Exports (in Local Currency Unit) of Bosnia and Herzegovina in 2005 to that in 2010?
Give a very brief answer. 0.74. What is the ratio of the Exports (in Local Currency Unit) of Hong Kong in 2005 to that in 2010?
Offer a terse response. 0.71. What is the ratio of the Exports (in Local Currency Unit) in Samoa in 2005 to that in 2010?
Keep it short and to the point. 0.75. What is the ratio of the Exports (in Local Currency Unit) of Tonga in 2005 to that in 2010?
Your response must be concise. 1.01. What is the ratio of the Exports (in Local Currency Unit) in Bosnia and Herzegovina in 2005 to that in 2011?
Offer a terse response. 0.66. What is the ratio of the Exports (in Local Currency Unit) of Hong Kong in 2005 to that in 2011?
Keep it short and to the point. 0.63. What is the ratio of the Exports (in Local Currency Unit) of Samoa in 2005 to that in 2011?
Your answer should be compact. 0.71. What is the ratio of the Exports (in Local Currency Unit) in Tonga in 2005 to that in 2011?
Offer a very short reply. 0.7. What is the ratio of the Exports (in Local Currency Unit) in Bosnia and Herzegovina in 2006 to that in 2007?
Ensure brevity in your answer.  1.15. What is the ratio of the Exports (in Local Currency Unit) in Hong Kong in 2006 to that in 2007?
Offer a very short reply. 0.9. What is the ratio of the Exports (in Local Currency Unit) in Samoa in 2006 to that in 2007?
Your response must be concise. 0.92. What is the ratio of the Exports (in Local Currency Unit) of Tonga in 2006 to that in 2007?
Keep it short and to the point. 1.17. What is the ratio of the Exports (in Local Currency Unit) in Bosnia and Herzegovina in 2006 to that in 2008?
Give a very brief answer. 1.03. What is the ratio of the Exports (in Local Currency Unit) in Hong Kong in 2006 to that in 2008?
Offer a terse response. 0.85. What is the ratio of the Exports (in Local Currency Unit) in Samoa in 2006 to that in 2008?
Offer a very short reply. 0.86. What is the ratio of the Exports (in Local Currency Unit) of Tonga in 2006 to that in 2008?
Offer a very short reply. 0.95. What is the ratio of the Exports (in Local Currency Unit) in Bosnia and Herzegovina in 2006 to that in 2009?
Keep it short and to the point. 1.13. What is the ratio of the Exports (in Local Currency Unit) of Hong Kong in 2006 to that in 2009?
Give a very brief answer. 0.96. What is the ratio of the Exports (in Local Currency Unit) of Samoa in 2006 to that in 2009?
Offer a terse response. 0.84. What is the ratio of the Exports (in Local Currency Unit) of Tonga in 2006 to that in 2009?
Provide a succinct answer. 0.92. What is the ratio of the Exports (in Local Currency Unit) in Bosnia and Herzegovina in 2006 to that in 2010?
Offer a very short reply. 0.93. What is the ratio of the Exports (in Local Currency Unit) in Hong Kong in 2006 to that in 2010?
Your answer should be very brief. 0.78. What is the ratio of the Exports (in Local Currency Unit) in Samoa in 2006 to that in 2010?
Offer a terse response. 0.85. What is the ratio of the Exports (in Local Currency Unit) in Tonga in 2006 to that in 2010?
Give a very brief answer. 0.95. What is the ratio of the Exports (in Local Currency Unit) of Bosnia and Herzegovina in 2006 to that in 2011?
Make the answer very short. 0.84. What is the ratio of the Exports (in Local Currency Unit) in Hong Kong in 2006 to that in 2011?
Provide a succinct answer. 0.7. What is the ratio of the Exports (in Local Currency Unit) in Samoa in 2006 to that in 2011?
Your answer should be compact. 0.8. What is the ratio of the Exports (in Local Currency Unit) in Tonga in 2006 to that in 2011?
Offer a very short reply. 0.67. What is the ratio of the Exports (in Local Currency Unit) of Bosnia and Herzegovina in 2007 to that in 2008?
Give a very brief answer. 0.89. What is the ratio of the Exports (in Local Currency Unit) of Hong Kong in 2007 to that in 2008?
Your answer should be compact. 0.94. What is the ratio of the Exports (in Local Currency Unit) in Samoa in 2007 to that in 2008?
Offer a terse response. 0.94. What is the ratio of the Exports (in Local Currency Unit) of Tonga in 2007 to that in 2008?
Offer a very short reply. 0.81. What is the ratio of the Exports (in Local Currency Unit) of Hong Kong in 2007 to that in 2009?
Make the answer very short. 1.06. What is the ratio of the Exports (in Local Currency Unit) of Samoa in 2007 to that in 2009?
Provide a short and direct response. 0.92. What is the ratio of the Exports (in Local Currency Unit) in Tonga in 2007 to that in 2009?
Your response must be concise. 0.78. What is the ratio of the Exports (in Local Currency Unit) of Bosnia and Herzegovina in 2007 to that in 2010?
Provide a short and direct response. 0.81. What is the ratio of the Exports (in Local Currency Unit) of Hong Kong in 2007 to that in 2010?
Offer a very short reply. 0.86. What is the ratio of the Exports (in Local Currency Unit) of Samoa in 2007 to that in 2010?
Provide a succinct answer. 0.93. What is the ratio of the Exports (in Local Currency Unit) in Tonga in 2007 to that in 2010?
Your answer should be compact. 0.81. What is the ratio of the Exports (in Local Currency Unit) in Bosnia and Herzegovina in 2007 to that in 2011?
Provide a short and direct response. 0.73. What is the ratio of the Exports (in Local Currency Unit) of Hong Kong in 2007 to that in 2011?
Provide a short and direct response. 0.77. What is the ratio of the Exports (in Local Currency Unit) of Tonga in 2007 to that in 2011?
Offer a terse response. 0.57. What is the ratio of the Exports (in Local Currency Unit) of Bosnia and Herzegovina in 2008 to that in 2009?
Keep it short and to the point. 1.1. What is the ratio of the Exports (in Local Currency Unit) of Hong Kong in 2008 to that in 2009?
Keep it short and to the point. 1.12. What is the ratio of the Exports (in Local Currency Unit) of Samoa in 2008 to that in 2009?
Ensure brevity in your answer.  0.98. What is the ratio of the Exports (in Local Currency Unit) of Tonga in 2008 to that in 2009?
Offer a very short reply. 0.97. What is the ratio of the Exports (in Local Currency Unit) of Bosnia and Herzegovina in 2008 to that in 2010?
Ensure brevity in your answer.  0.91. What is the ratio of the Exports (in Local Currency Unit) in Hong Kong in 2008 to that in 2010?
Your answer should be very brief. 0.91. What is the ratio of the Exports (in Local Currency Unit) of Samoa in 2008 to that in 2010?
Give a very brief answer. 0.99. What is the ratio of the Exports (in Local Currency Unit) of Bosnia and Herzegovina in 2008 to that in 2011?
Make the answer very short. 0.82. What is the ratio of the Exports (in Local Currency Unit) of Hong Kong in 2008 to that in 2011?
Provide a short and direct response. 0.82. What is the ratio of the Exports (in Local Currency Unit) in Samoa in 2008 to that in 2011?
Provide a succinct answer. 0.93. What is the ratio of the Exports (in Local Currency Unit) in Tonga in 2008 to that in 2011?
Keep it short and to the point. 0.7. What is the ratio of the Exports (in Local Currency Unit) of Bosnia and Herzegovina in 2009 to that in 2010?
Offer a very short reply. 0.82. What is the ratio of the Exports (in Local Currency Unit) of Hong Kong in 2009 to that in 2010?
Ensure brevity in your answer.  0.81. What is the ratio of the Exports (in Local Currency Unit) of Samoa in 2009 to that in 2010?
Make the answer very short. 1.01. What is the ratio of the Exports (in Local Currency Unit) of Tonga in 2009 to that in 2010?
Your answer should be compact. 1.04. What is the ratio of the Exports (in Local Currency Unit) in Bosnia and Herzegovina in 2009 to that in 2011?
Offer a terse response. 0.74. What is the ratio of the Exports (in Local Currency Unit) of Hong Kong in 2009 to that in 2011?
Your answer should be compact. 0.73. What is the ratio of the Exports (in Local Currency Unit) in Samoa in 2009 to that in 2011?
Provide a short and direct response. 0.95. What is the ratio of the Exports (in Local Currency Unit) of Tonga in 2009 to that in 2011?
Make the answer very short. 0.72. What is the ratio of the Exports (in Local Currency Unit) of Bosnia and Herzegovina in 2010 to that in 2011?
Your response must be concise. 0.9. What is the ratio of the Exports (in Local Currency Unit) in Hong Kong in 2010 to that in 2011?
Give a very brief answer. 0.89. What is the ratio of the Exports (in Local Currency Unit) in Samoa in 2010 to that in 2011?
Offer a very short reply. 0.94. What is the ratio of the Exports (in Local Currency Unit) of Tonga in 2010 to that in 2011?
Your response must be concise. 0.7. What is the difference between the highest and the second highest Exports (in Local Currency Unit) in Bosnia and Herzegovina?
Your answer should be compact. 8.71e+08. What is the difference between the highest and the second highest Exports (in Local Currency Unit) of Hong Kong?
Provide a short and direct response. 4.64e+11. What is the difference between the highest and the second highest Exports (in Local Currency Unit) of Samoa?
Your response must be concise. 2.37e+07. What is the difference between the highest and the second highest Exports (in Local Currency Unit) of Tonga?
Provide a succinct answer. 3.53e+07. What is the difference between the highest and the lowest Exports (in Local Currency Unit) in Bosnia and Herzegovina?
Offer a terse response. 2.82e+09. What is the difference between the highest and the lowest Exports (in Local Currency Unit) of Hong Kong?
Give a very brief answer. 1.61e+12. What is the difference between the highest and the lowest Exports (in Local Currency Unit) of Samoa?
Ensure brevity in your answer.  1.49e+08. What is the difference between the highest and the lowest Exports (in Local Currency Unit) of Tonga?
Provide a short and direct response. 5.55e+07. 